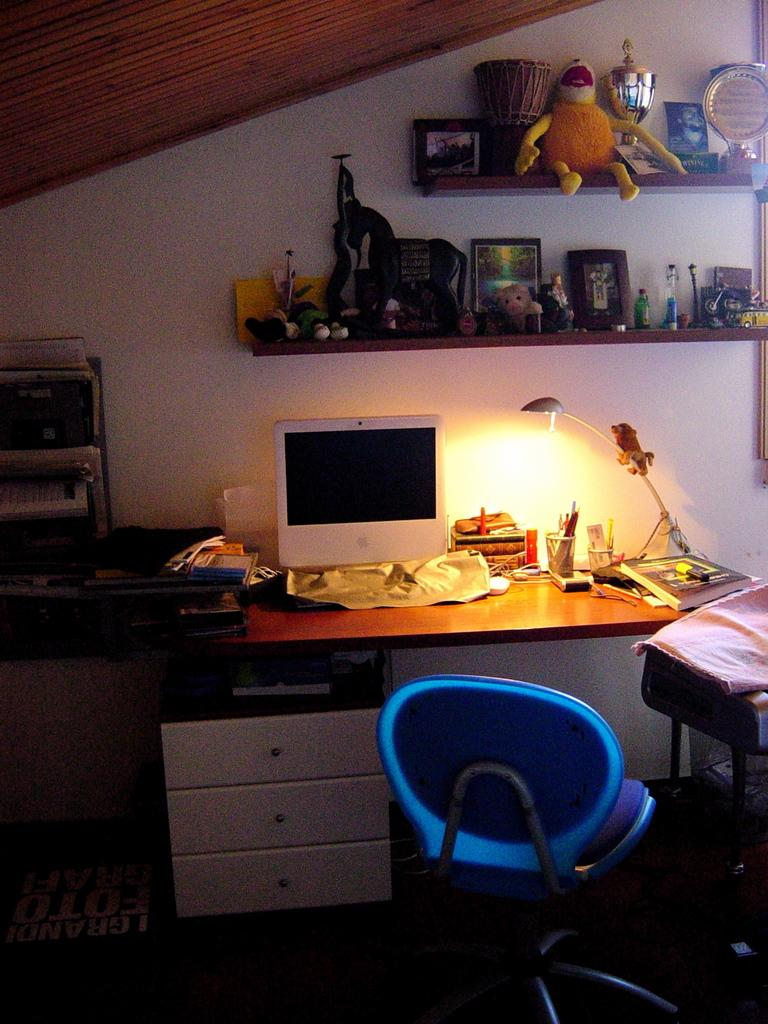What type of furniture is present in the image? There is a chair and a table in the image. What is placed on the table? There is a monitor on the table. Can you describe any other items in the image? There are additional unspecified items, referred to as "few stuffs," in the image. What type of copper art can be seen on the chair in the image? There is no copper art present on the chair in the image. How many lizards are sitting on the table in the image? There are no lizards present in the image. 